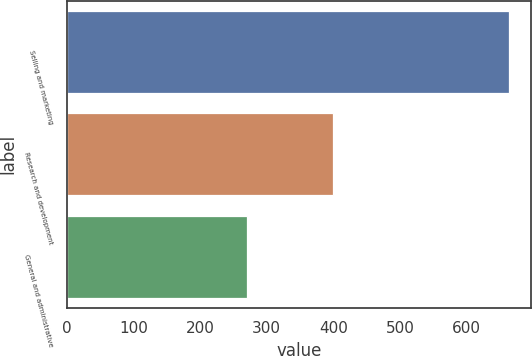Convert chart to OTSL. <chart><loc_0><loc_0><loc_500><loc_500><bar_chart><fcel>Selling and marketing<fcel>Research and development<fcel>General and administrative<nl><fcel>664.1<fcel>399<fcel>270.3<nl></chart> 